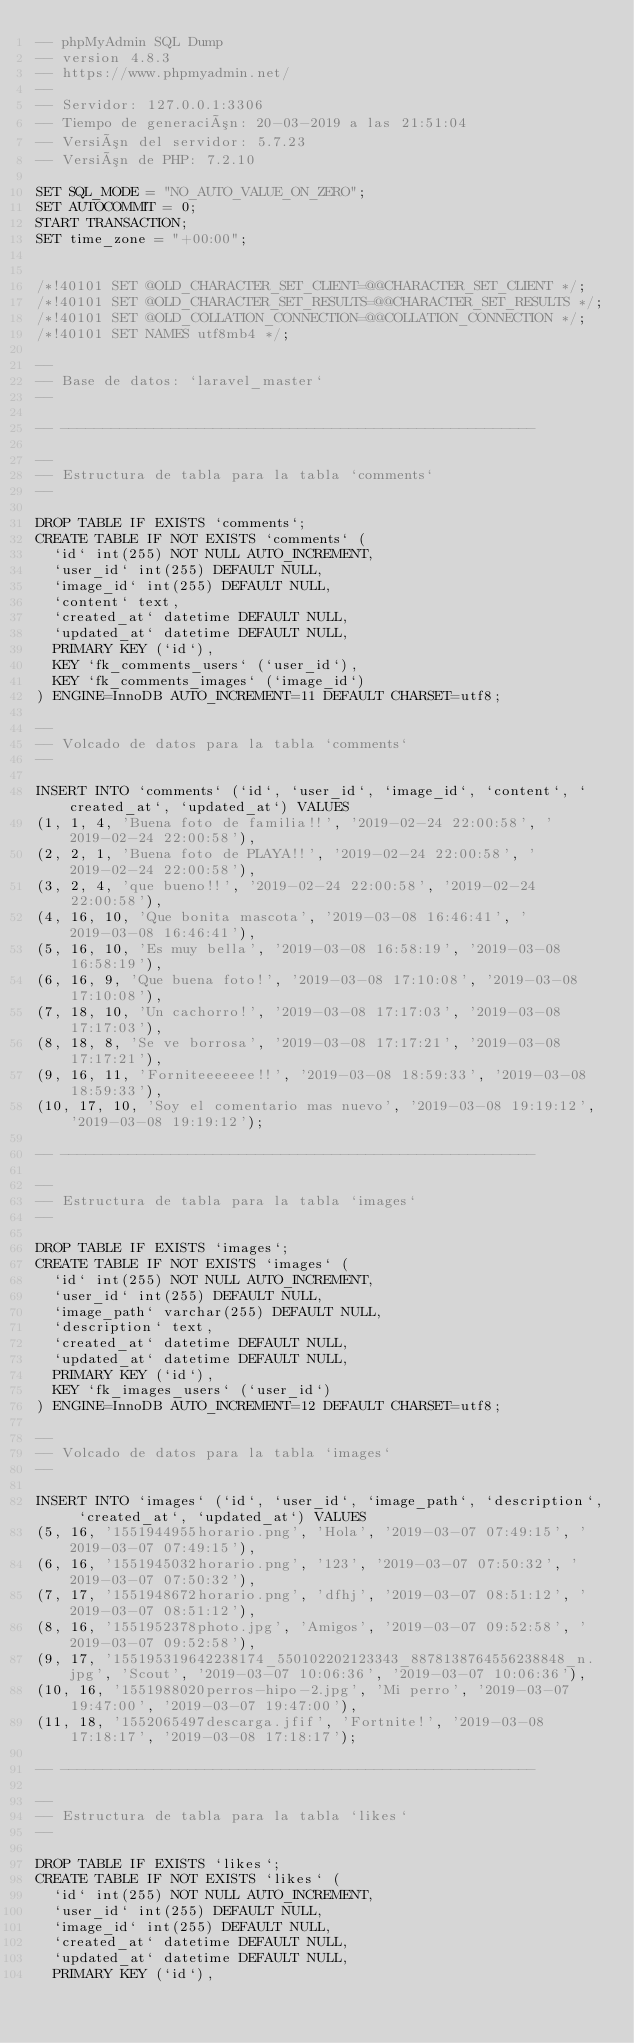Convert code to text. <code><loc_0><loc_0><loc_500><loc_500><_SQL_>-- phpMyAdmin SQL Dump
-- version 4.8.3
-- https://www.phpmyadmin.net/
--
-- Servidor: 127.0.0.1:3306
-- Tiempo de generación: 20-03-2019 a las 21:51:04
-- Versión del servidor: 5.7.23
-- Versión de PHP: 7.2.10

SET SQL_MODE = "NO_AUTO_VALUE_ON_ZERO";
SET AUTOCOMMIT = 0;
START TRANSACTION;
SET time_zone = "+00:00";


/*!40101 SET @OLD_CHARACTER_SET_CLIENT=@@CHARACTER_SET_CLIENT */;
/*!40101 SET @OLD_CHARACTER_SET_RESULTS=@@CHARACTER_SET_RESULTS */;
/*!40101 SET @OLD_COLLATION_CONNECTION=@@COLLATION_CONNECTION */;
/*!40101 SET NAMES utf8mb4 */;

--
-- Base de datos: `laravel_master`
--

-- --------------------------------------------------------

--
-- Estructura de tabla para la tabla `comments`
--

DROP TABLE IF EXISTS `comments`;
CREATE TABLE IF NOT EXISTS `comments` (
  `id` int(255) NOT NULL AUTO_INCREMENT,
  `user_id` int(255) DEFAULT NULL,
  `image_id` int(255) DEFAULT NULL,
  `content` text,
  `created_at` datetime DEFAULT NULL,
  `updated_at` datetime DEFAULT NULL,
  PRIMARY KEY (`id`),
  KEY `fk_comments_users` (`user_id`),
  KEY `fk_comments_images` (`image_id`)
) ENGINE=InnoDB AUTO_INCREMENT=11 DEFAULT CHARSET=utf8;

--
-- Volcado de datos para la tabla `comments`
--

INSERT INTO `comments` (`id`, `user_id`, `image_id`, `content`, `created_at`, `updated_at`) VALUES
(1, 1, 4, 'Buena foto de familia!!', '2019-02-24 22:00:58', '2019-02-24 22:00:58'),
(2, 2, 1, 'Buena foto de PLAYA!!', '2019-02-24 22:00:58', '2019-02-24 22:00:58'),
(3, 2, 4, 'que bueno!!', '2019-02-24 22:00:58', '2019-02-24 22:00:58'),
(4, 16, 10, 'Que bonita mascota', '2019-03-08 16:46:41', '2019-03-08 16:46:41'),
(5, 16, 10, 'Es muy bella', '2019-03-08 16:58:19', '2019-03-08 16:58:19'),
(6, 16, 9, 'Que buena foto!', '2019-03-08 17:10:08', '2019-03-08 17:10:08'),
(7, 18, 10, 'Un cachorro!', '2019-03-08 17:17:03', '2019-03-08 17:17:03'),
(8, 18, 8, 'Se ve borrosa', '2019-03-08 17:17:21', '2019-03-08 17:17:21'),
(9, 16, 11, 'Forniteeeeeee!!', '2019-03-08 18:59:33', '2019-03-08 18:59:33'),
(10, 17, 10, 'Soy el comentario mas nuevo', '2019-03-08 19:19:12', '2019-03-08 19:19:12');

-- --------------------------------------------------------

--
-- Estructura de tabla para la tabla `images`
--

DROP TABLE IF EXISTS `images`;
CREATE TABLE IF NOT EXISTS `images` (
  `id` int(255) NOT NULL AUTO_INCREMENT,
  `user_id` int(255) DEFAULT NULL,
  `image_path` varchar(255) DEFAULT NULL,
  `description` text,
  `created_at` datetime DEFAULT NULL,
  `updated_at` datetime DEFAULT NULL,
  PRIMARY KEY (`id`),
  KEY `fk_images_users` (`user_id`)
) ENGINE=InnoDB AUTO_INCREMENT=12 DEFAULT CHARSET=utf8;

--
-- Volcado de datos para la tabla `images`
--

INSERT INTO `images` (`id`, `user_id`, `image_path`, `description`, `created_at`, `updated_at`) VALUES
(5, 16, '1551944955horario.png', 'Hola', '2019-03-07 07:49:15', '2019-03-07 07:49:15'),
(6, 16, '1551945032horario.png', '123', '2019-03-07 07:50:32', '2019-03-07 07:50:32'),
(7, 17, '1551948672horario.png', 'dfhj', '2019-03-07 08:51:12', '2019-03-07 08:51:12'),
(8, 16, '1551952378photo.jpg', 'Amigos', '2019-03-07 09:52:58', '2019-03-07 09:52:58'),
(9, 17, '155195319642238174_550102202123343_8878138764556238848_n.jpg', 'Scout', '2019-03-07 10:06:36', '2019-03-07 10:06:36'),
(10, 16, '1551988020perros-hipo-2.jpg', 'Mi perro', '2019-03-07 19:47:00', '2019-03-07 19:47:00'),
(11, 18, '1552065497descarga.jfif', 'Fortnite!', '2019-03-08 17:18:17', '2019-03-08 17:18:17');

-- --------------------------------------------------------

--
-- Estructura de tabla para la tabla `likes`
--

DROP TABLE IF EXISTS `likes`;
CREATE TABLE IF NOT EXISTS `likes` (
  `id` int(255) NOT NULL AUTO_INCREMENT,
  `user_id` int(255) DEFAULT NULL,
  `image_id` int(255) DEFAULT NULL,
  `created_at` datetime DEFAULT NULL,
  `updated_at` datetime DEFAULT NULL,
  PRIMARY KEY (`id`),</code> 